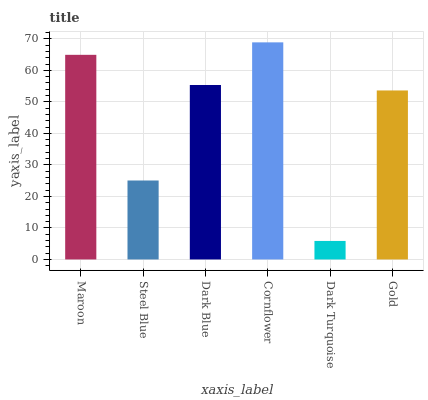Is Dark Turquoise the minimum?
Answer yes or no. Yes. Is Cornflower the maximum?
Answer yes or no. Yes. Is Steel Blue the minimum?
Answer yes or no. No. Is Steel Blue the maximum?
Answer yes or no. No. Is Maroon greater than Steel Blue?
Answer yes or no. Yes. Is Steel Blue less than Maroon?
Answer yes or no. Yes. Is Steel Blue greater than Maroon?
Answer yes or no. No. Is Maroon less than Steel Blue?
Answer yes or no. No. Is Dark Blue the high median?
Answer yes or no. Yes. Is Gold the low median?
Answer yes or no. Yes. Is Steel Blue the high median?
Answer yes or no. No. Is Steel Blue the low median?
Answer yes or no. No. 